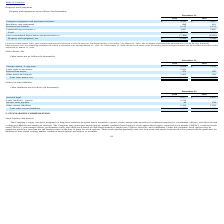From Immersion's financial document, What is the value of Computer equipment and purchased software in 2019 and 2018 respectively? The document shows two values: $3,011 and $3,167 (in thousands). From the document: "mputer equipment and purchased software $ 3,011 $ 3,167 Computer equipment and purchased software $ 3,011 $ 3,167..." Also, What was the net book value of SJ Facility leasehold improvements in 2019? According to the financial document, $0.9 million. The relevant text states: "alue of the SJ Facility leasehold improvements was $0.9 million and will be fully amortized by March 31, 2020...." Also, What is the value of Machinery and equipment in 2019 and 2018 respectively? The document shows two values: 699 and 821 (in thousands). From the document: "Machinery and equipment 699 821 Machinery and equipment 699 821..." Additionally, In which year was Machinery and equipment less than 700 thousands? According to the financial document, 2019. The relevant text states: "2019 2018..." Also, can you calculate: What was the average Furniture and fixtures for 2018 and 2019? To answer this question, I need to perform calculations using the financial data. The calculation is: (1,115 + 1,113) / 2, which equals 1114 (in thousands). This is based on the information: "Furniture and fixtures 1,115 1,113 Furniture and fixtures 1,115 1,113..." The key data points involved are: 1,113, 1,115. Also, can you calculate: What was the change in the Property and equipment, net from 2018 to 2019? Based on the calculation: 1,226 - 2,343, the result is -1117 (in thousands). This is based on the information: "Property and equipment, net $ 1,226 $ 2,343 Property and equipment, net $ 1,226 $ 2,343..." The key data points involved are: 1,226, 2,343. 